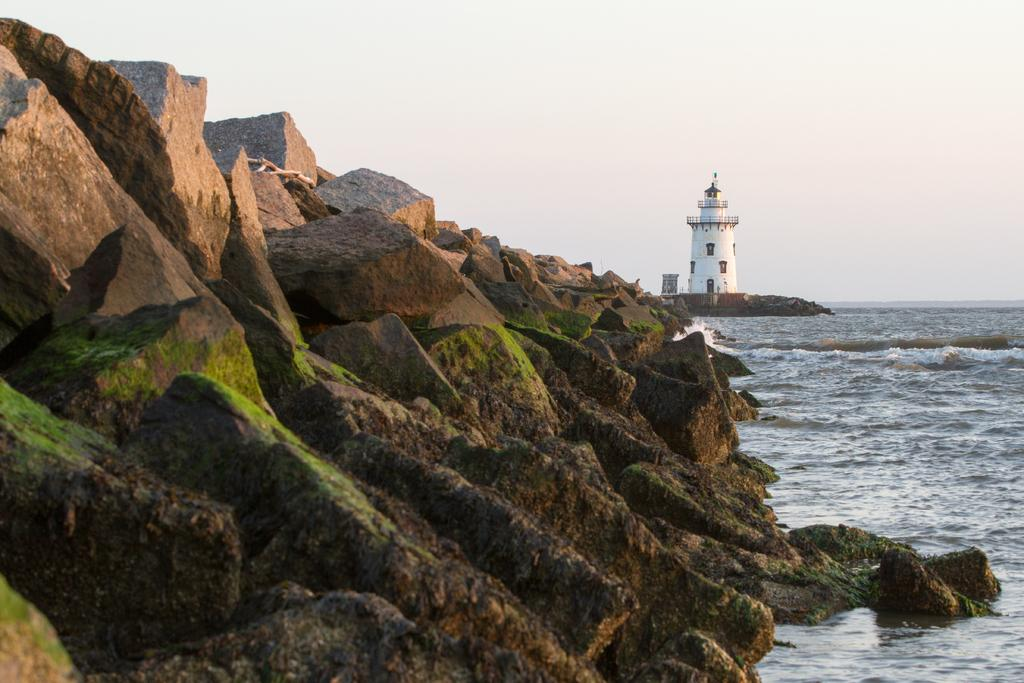What type of natural formation can be seen in the image? There are ocean rocks in the image. What else is visible in the image besides the ocean rocks? There is water visible in the image. What structure can be seen in the background of the image? There is a lighthouse in the background of the image. How would you describe the weather in the image? The sky is clear in the background of the image, suggesting good weather. What type of pets can be seen playing on the rocks in the image? There are no pets visible in the image; it features ocean rocks, water, a lighthouse, and a clear sky. 